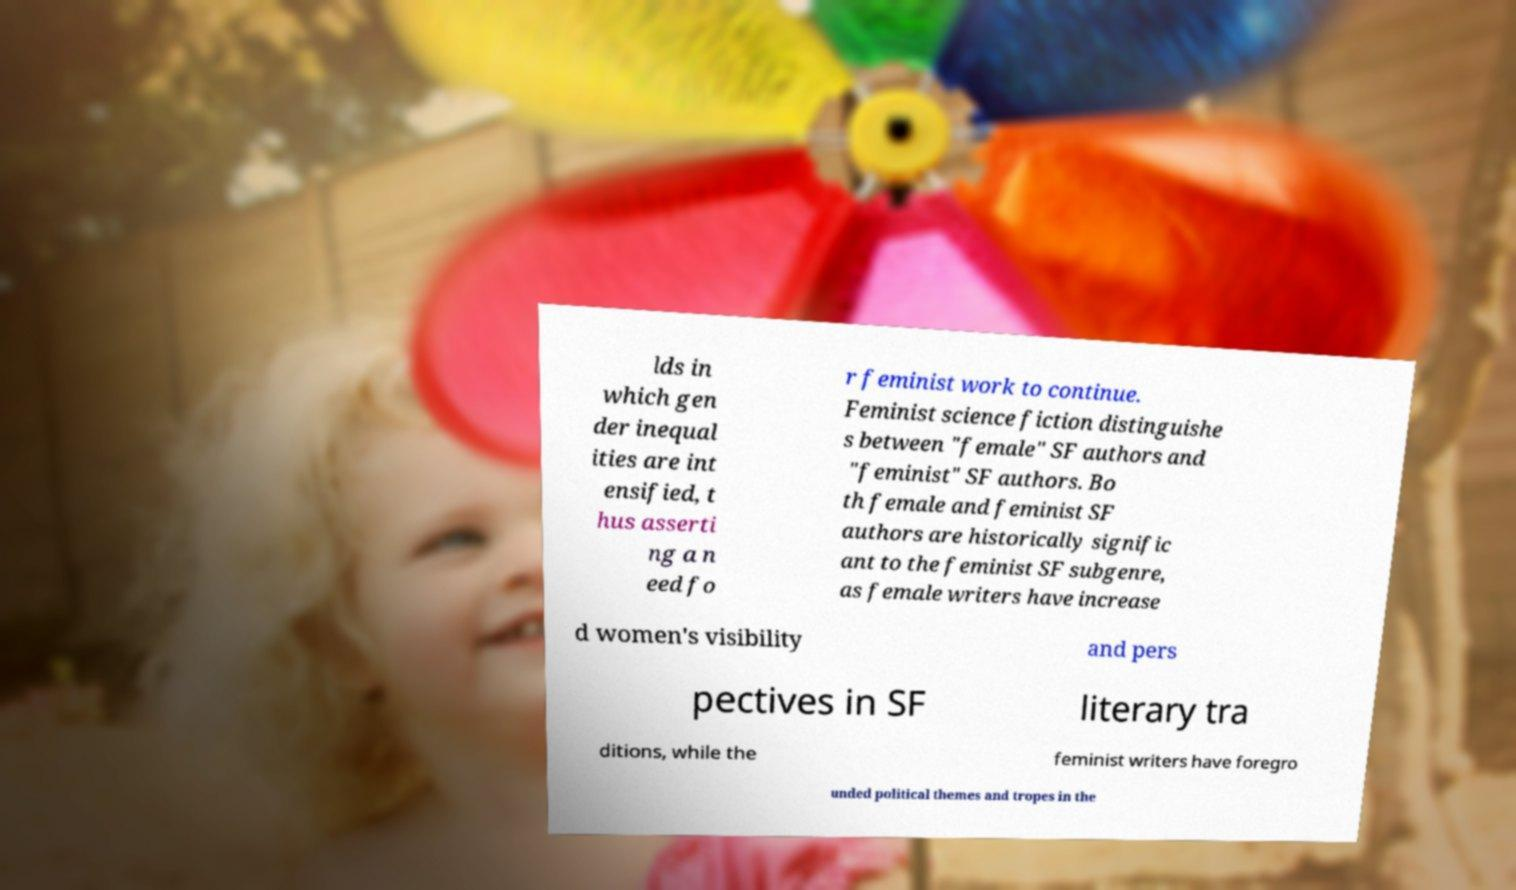For documentation purposes, I need the text within this image transcribed. Could you provide that? lds in which gen der inequal ities are int ensified, t hus asserti ng a n eed fo r feminist work to continue. Feminist science fiction distinguishe s between "female" SF authors and "feminist" SF authors. Bo th female and feminist SF authors are historically signific ant to the feminist SF subgenre, as female writers have increase d women's visibility and pers pectives in SF literary tra ditions, while the feminist writers have foregro unded political themes and tropes in the 